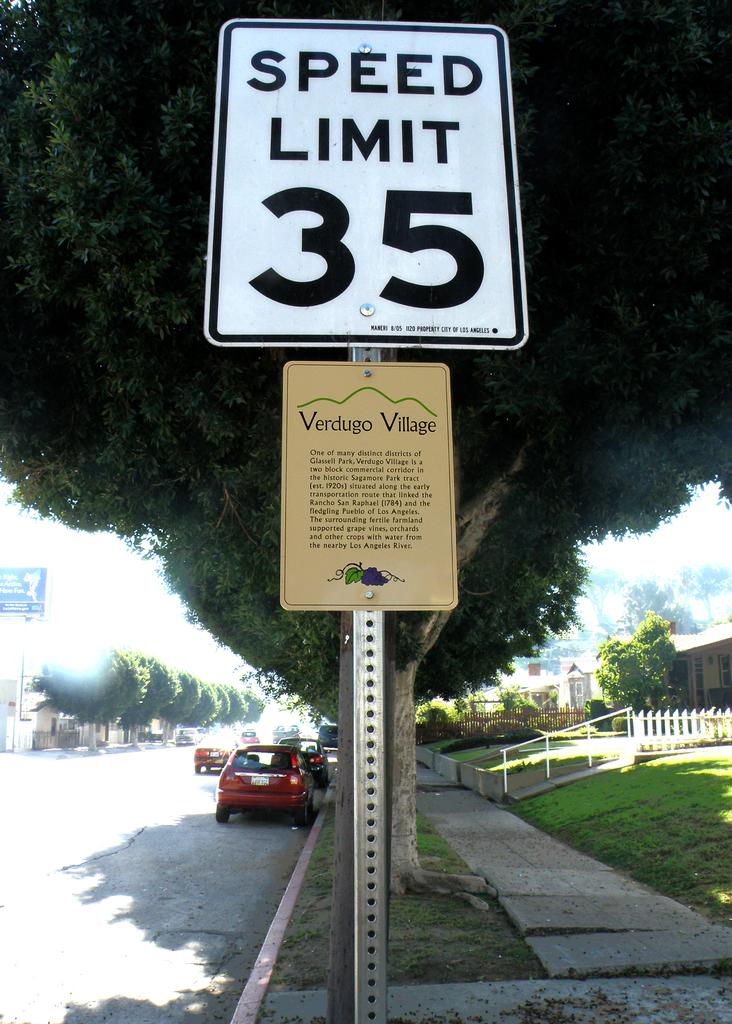What village is mentioned?
Make the answer very short. Verdugo. 